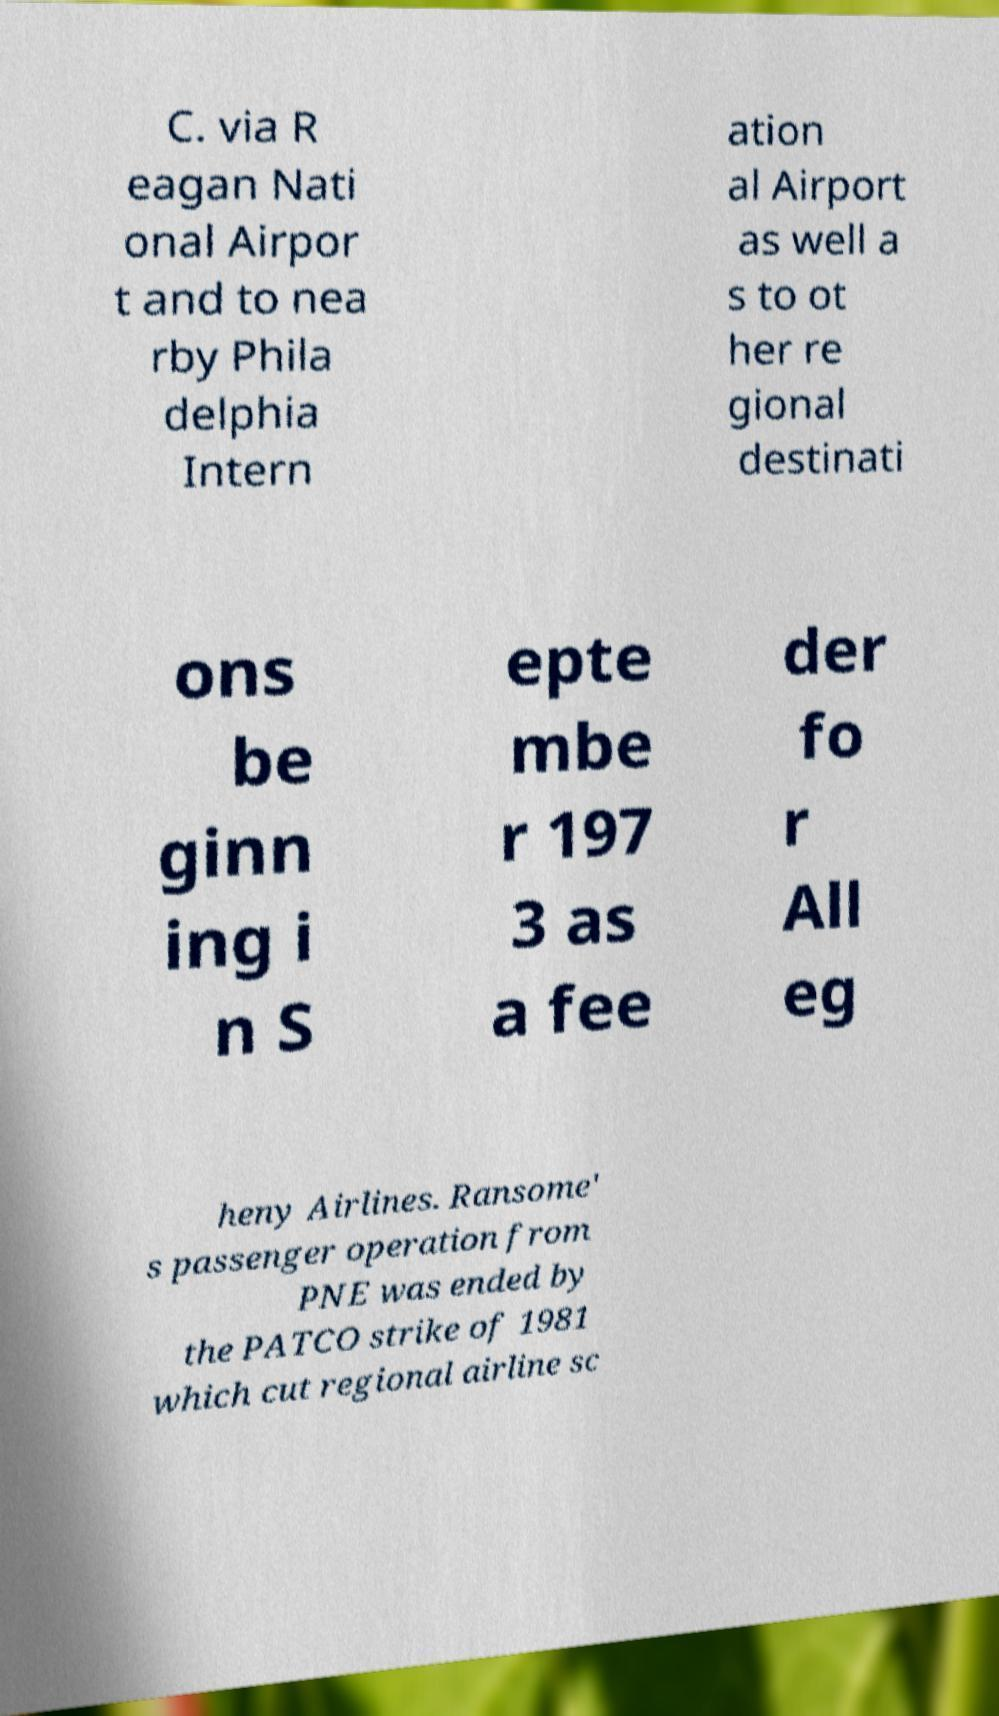I need the written content from this picture converted into text. Can you do that? C. via R eagan Nati onal Airpor t and to nea rby Phila delphia Intern ation al Airport as well a s to ot her re gional destinati ons be ginn ing i n S epte mbe r 197 3 as a fee der fo r All eg heny Airlines. Ransome' s passenger operation from PNE was ended by the PATCO strike of 1981 which cut regional airline sc 